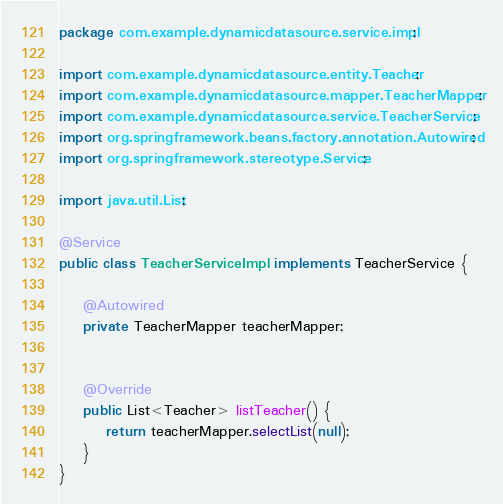Convert code to text. <code><loc_0><loc_0><loc_500><loc_500><_Java_>package com.example.dynamicdatasource.service.impl;

import com.example.dynamicdatasource.entity.Teacher;
import com.example.dynamicdatasource.mapper.TeacherMapper;
import com.example.dynamicdatasource.service.TeacherService;
import org.springframework.beans.factory.annotation.Autowired;
import org.springframework.stereotype.Service;

import java.util.List;

@Service
public class TeacherServiceImpl implements TeacherService {

    @Autowired
    private TeacherMapper teacherMapper;


    @Override
    public List<Teacher> listTeacher() {
        return teacherMapper.selectList(null);
    }
}
</code> 